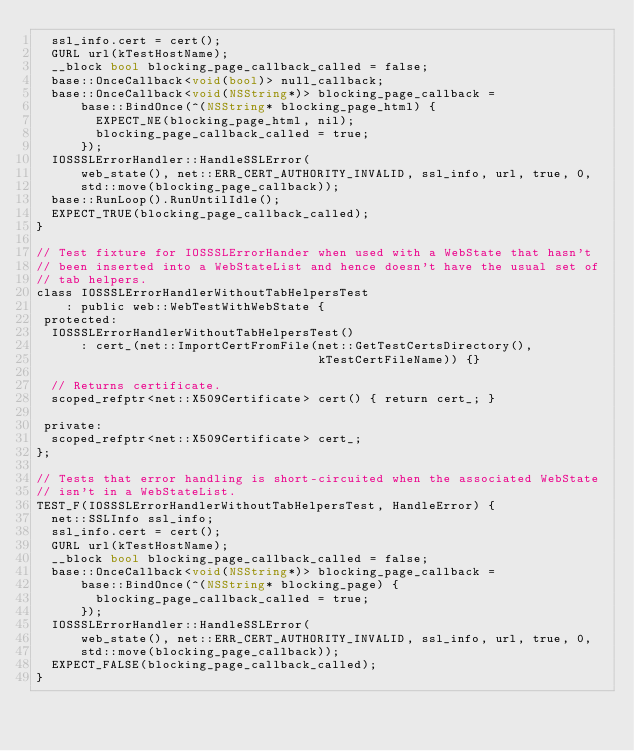<code> <loc_0><loc_0><loc_500><loc_500><_ObjectiveC_>  ssl_info.cert = cert();
  GURL url(kTestHostName);
  __block bool blocking_page_callback_called = false;
  base::OnceCallback<void(bool)> null_callback;
  base::OnceCallback<void(NSString*)> blocking_page_callback =
      base::BindOnce(^(NSString* blocking_page_html) {
        EXPECT_NE(blocking_page_html, nil);
        blocking_page_callback_called = true;
      });
  IOSSSLErrorHandler::HandleSSLError(
      web_state(), net::ERR_CERT_AUTHORITY_INVALID, ssl_info, url, true, 0,
      std::move(blocking_page_callback));
  base::RunLoop().RunUntilIdle();
  EXPECT_TRUE(blocking_page_callback_called);
}

// Test fixture for IOSSSLErrorHander when used with a WebState that hasn't
// been inserted into a WebStateList and hence doesn't have the usual set of
// tab helpers.
class IOSSSLErrorHandlerWithoutTabHelpersTest
    : public web::WebTestWithWebState {
 protected:
  IOSSSLErrorHandlerWithoutTabHelpersTest()
      : cert_(net::ImportCertFromFile(net::GetTestCertsDirectory(),
                                      kTestCertFileName)) {}

  // Returns certificate.
  scoped_refptr<net::X509Certificate> cert() { return cert_; }

 private:
  scoped_refptr<net::X509Certificate> cert_;
};

// Tests that error handling is short-circuited when the associated WebState
// isn't in a WebStateList.
TEST_F(IOSSSLErrorHandlerWithoutTabHelpersTest, HandleError) {
  net::SSLInfo ssl_info;
  ssl_info.cert = cert();
  GURL url(kTestHostName);
  __block bool blocking_page_callback_called = false;
  base::OnceCallback<void(NSString*)> blocking_page_callback =
      base::BindOnce(^(NSString* blocking_page) {
        blocking_page_callback_called = true;
      });
  IOSSSLErrorHandler::HandleSSLError(
      web_state(), net::ERR_CERT_AUTHORITY_INVALID, ssl_info, url, true, 0,
      std::move(blocking_page_callback));
  EXPECT_FALSE(blocking_page_callback_called);
}
</code> 